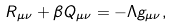<formula> <loc_0><loc_0><loc_500><loc_500>R _ { \mu \nu } + \beta Q _ { \mu \nu } = - \Lambda g _ { \mu \nu } ,</formula> 